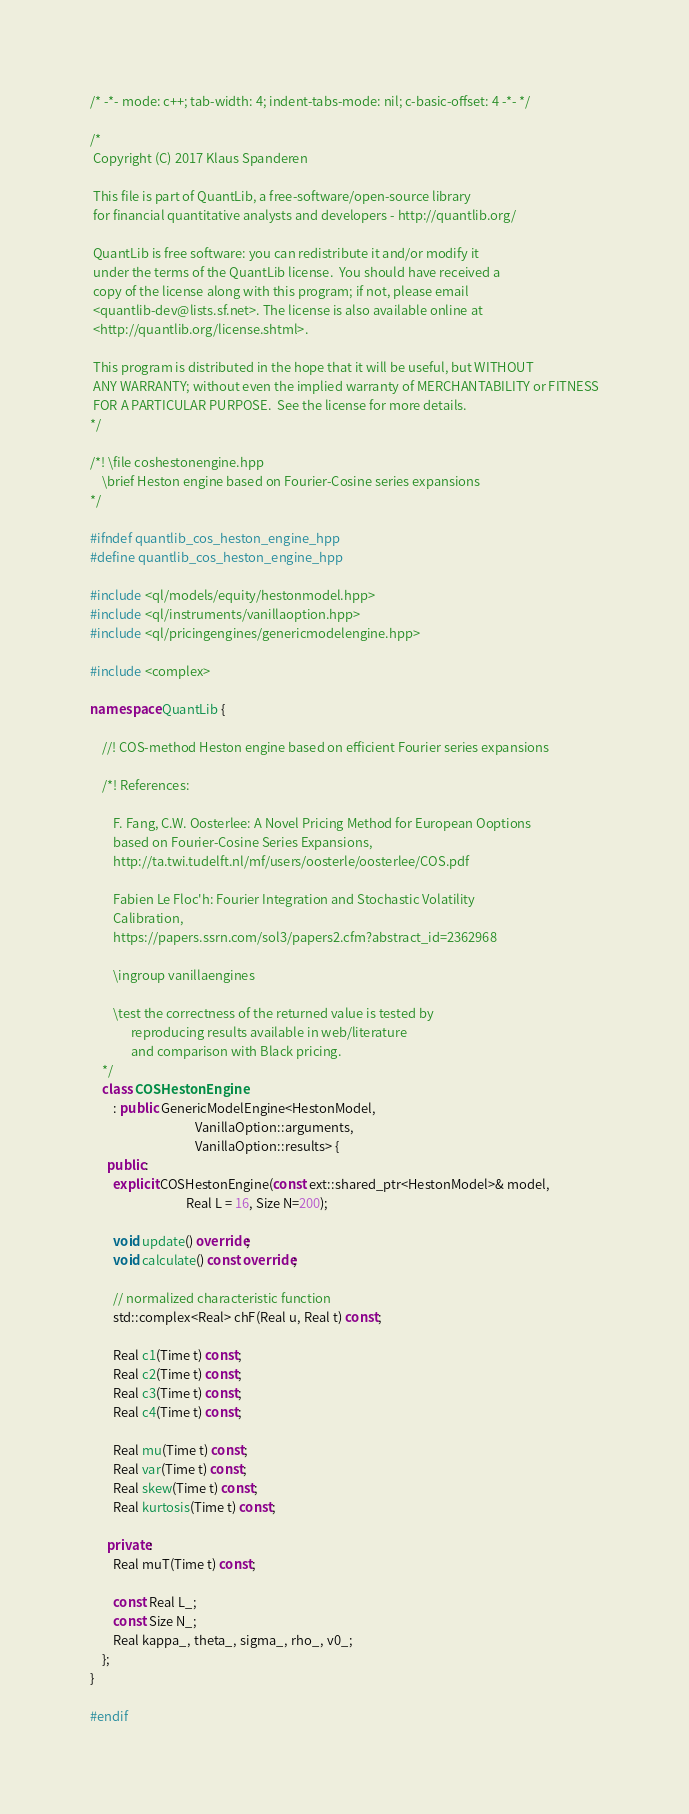Convert code to text. <code><loc_0><loc_0><loc_500><loc_500><_C++_>/* -*- mode: c++; tab-width: 4; indent-tabs-mode: nil; c-basic-offset: 4 -*- */

/*
 Copyright (C) 2017 Klaus Spanderen

 This file is part of QuantLib, a free-software/open-source library
 for financial quantitative analysts and developers - http://quantlib.org/

 QuantLib is free software: you can redistribute it and/or modify it
 under the terms of the QuantLib license.  You should have received a
 copy of the license along with this program; if not, please email
 <quantlib-dev@lists.sf.net>. The license is also available online at
 <http://quantlib.org/license.shtml>.

 This program is distributed in the hope that it will be useful, but WITHOUT
 ANY WARRANTY; without even the implied warranty of MERCHANTABILITY or FITNESS
 FOR A PARTICULAR PURPOSE.  See the license for more details.
*/

/*! \file coshestonengine.hpp
    \brief Heston engine based on Fourier-Cosine series expansions
*/

#ifndef quantlib_cos_heston_engine_hpp
#define quantlib_cos_heston_engine_hpp

#include <ql/models/equity/hestonmodel.hpp>
#include <ql/instruments/vanillaoption.hpp>
#include <ql/pricingengines/genericmodelengine.hpp>

#include <complex>

namespace QuantLib {

    //! COS-method Heston engine based on efficient Fourier series expansions

    /*! References:

        F. Fang, C.W. Oosterlee: A Novel Pricing Method for European Ooptions
        based on Fourier-Cosine Series Expansions,
        http://ta.twi.tudelft.nl/mf/users/oosterle/oosterlee/COS.pdf

        Fabien Le Floc'h: Fourier Integration and Stochastic Volatility
        Calibration,
        https://papers.ssrn.com/sol3/papers2.cfm?abstract_id=2362968

        \ingroup vanillaengines

        \test the correctness of the returned value is tested by
              reproducing results available in web/literature
              and comparison with Black pricing.
    */
    class COSHestonEngine
        : public GenericModelEngine<HestonModel,
                                    VanillaOption::arguments,
                                    VanillaOption::results> {
      public:
        explicit COSHestonEngine(const ext::shared_ptr<HestonModel>& model,
                                 Real L = 16, Size N=200);

        void update() override;
        void calculate() const override;

        // normalized characteristic function
        std::complex<Real> chF(Real u, Real t) const;

        Real c1(Time t) const;
        Real c2(Time t) const;
        Real c3(Time t) const;
        Real c4(Time t) const;

        Real mu(Time t) const;
        Real var(Time t) const;
        Real skew(Time t) const;
        Real kurtosis(Time t) const;

      private:
        Real muT(Time t) const;

        const Real L_;
        const Size N_;
        Real kappa_, theta_, sigma_, rho_, v0_;
    };
}

#endif
</code> 